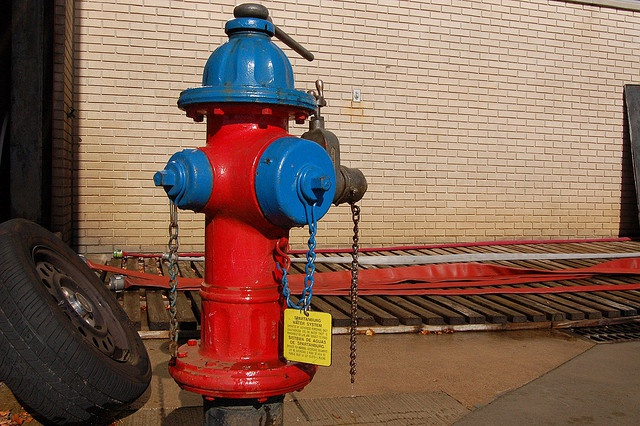Describe the objects in this image and their specific colors. I can see a fire hydrant in black, blue, and brown tones in this image. 